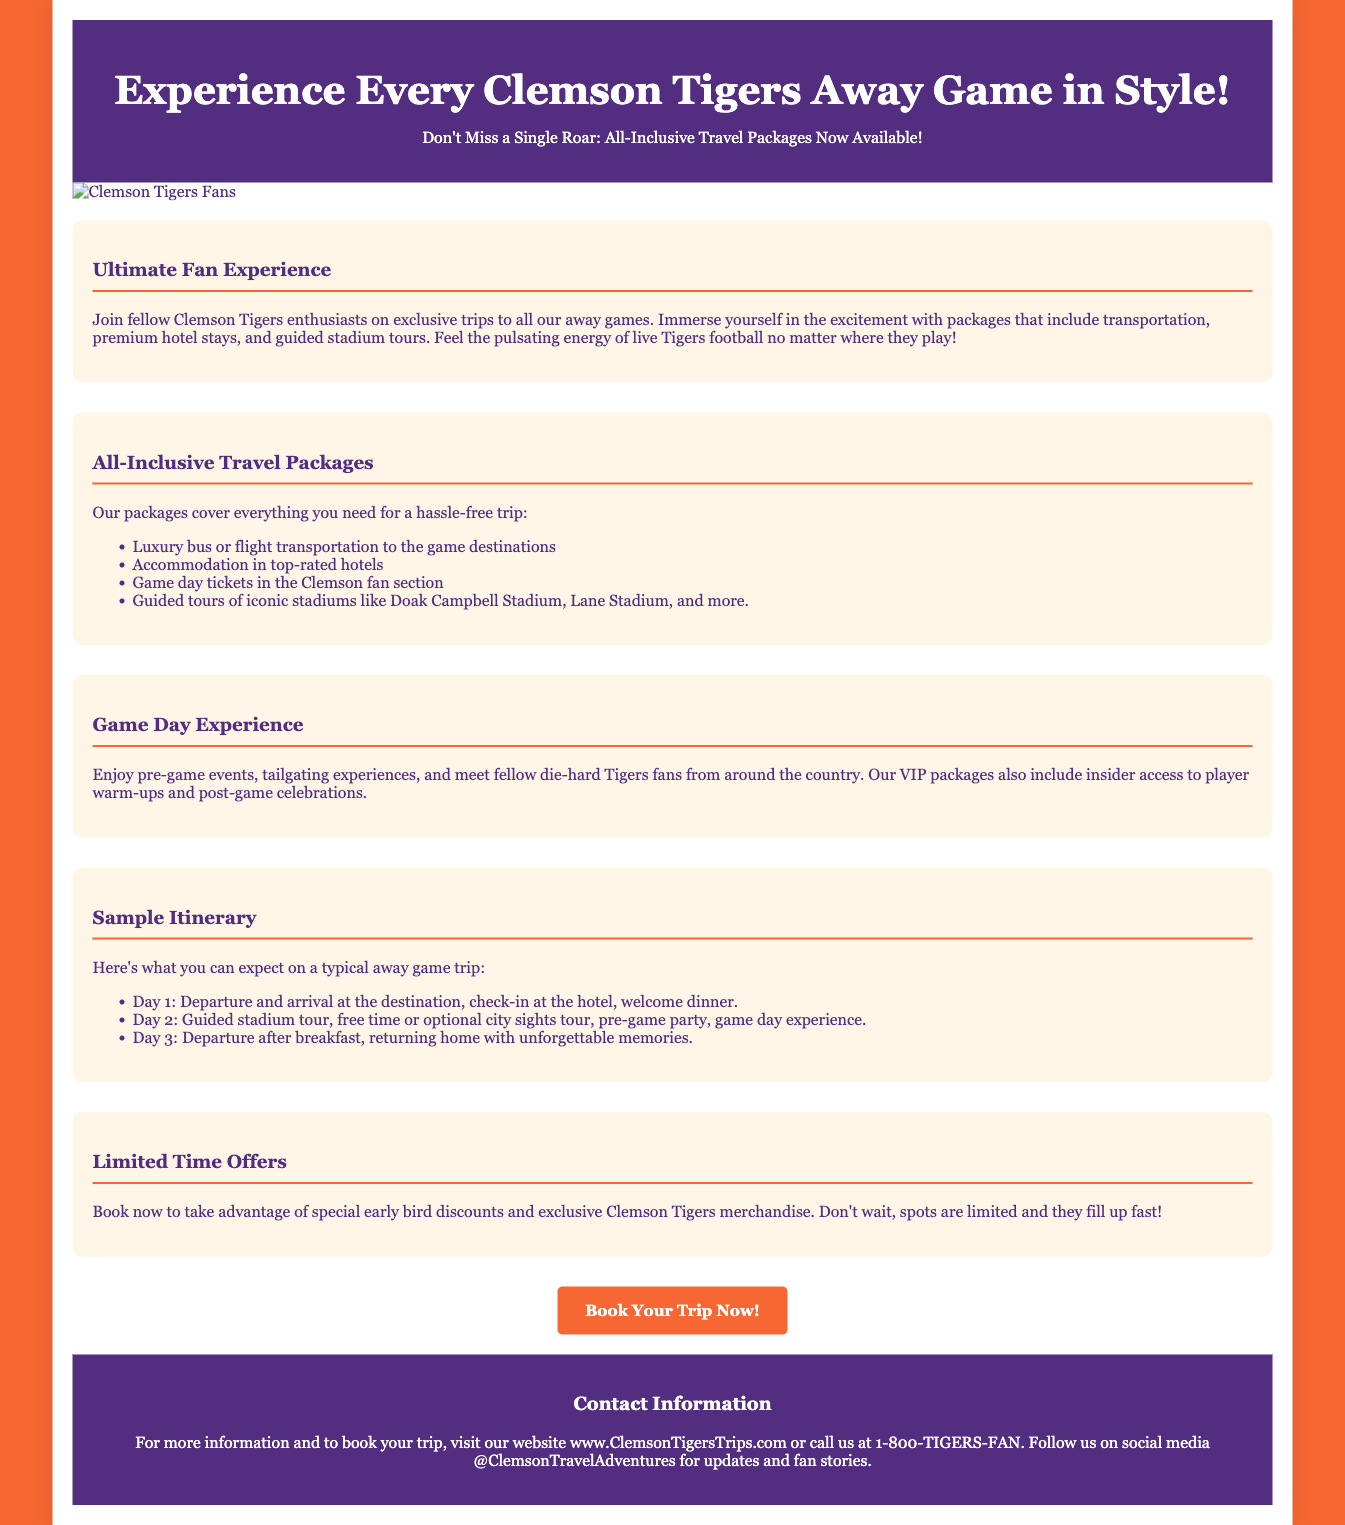What is the title of the advertisement? The title of the advertisement is prominently displayed in the header of the document.
Answer: Experience Every Clemson Tigers Away Game in Style! What services are included in the travel packages? The packages cover various services mentioned in the All-Inclusive Travel Packages section.
Answer: Transportation, hotel stays, game day tickets, guided stadium tours How many days does a typical away game itinerary last? The sample itinerary indicates the duration of the trip.
Answer: 3 days What must fans do to take advantage of limited-time offers? The text in the Limited Time Offers section specifies what fans should do.
Answer: Book now What is the main color scheme of the advertisement? The document features distinct colors throughout, particularly in the background and header.
Answer: Orange and purple 